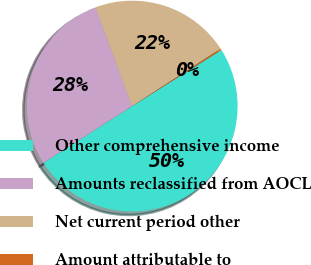<chart> <loc_0><loc_0><loc_500><loc_500><pie_chart><fcel>Other comprehensive income<fcel>Amounts reclassified from AOCL<fcel>Net current period other<fcel>Amount attributable to<nl><fcel>49.89%<fcel>28.38%<fcel>21.51%<fcel>0.23%<nl></chart> 